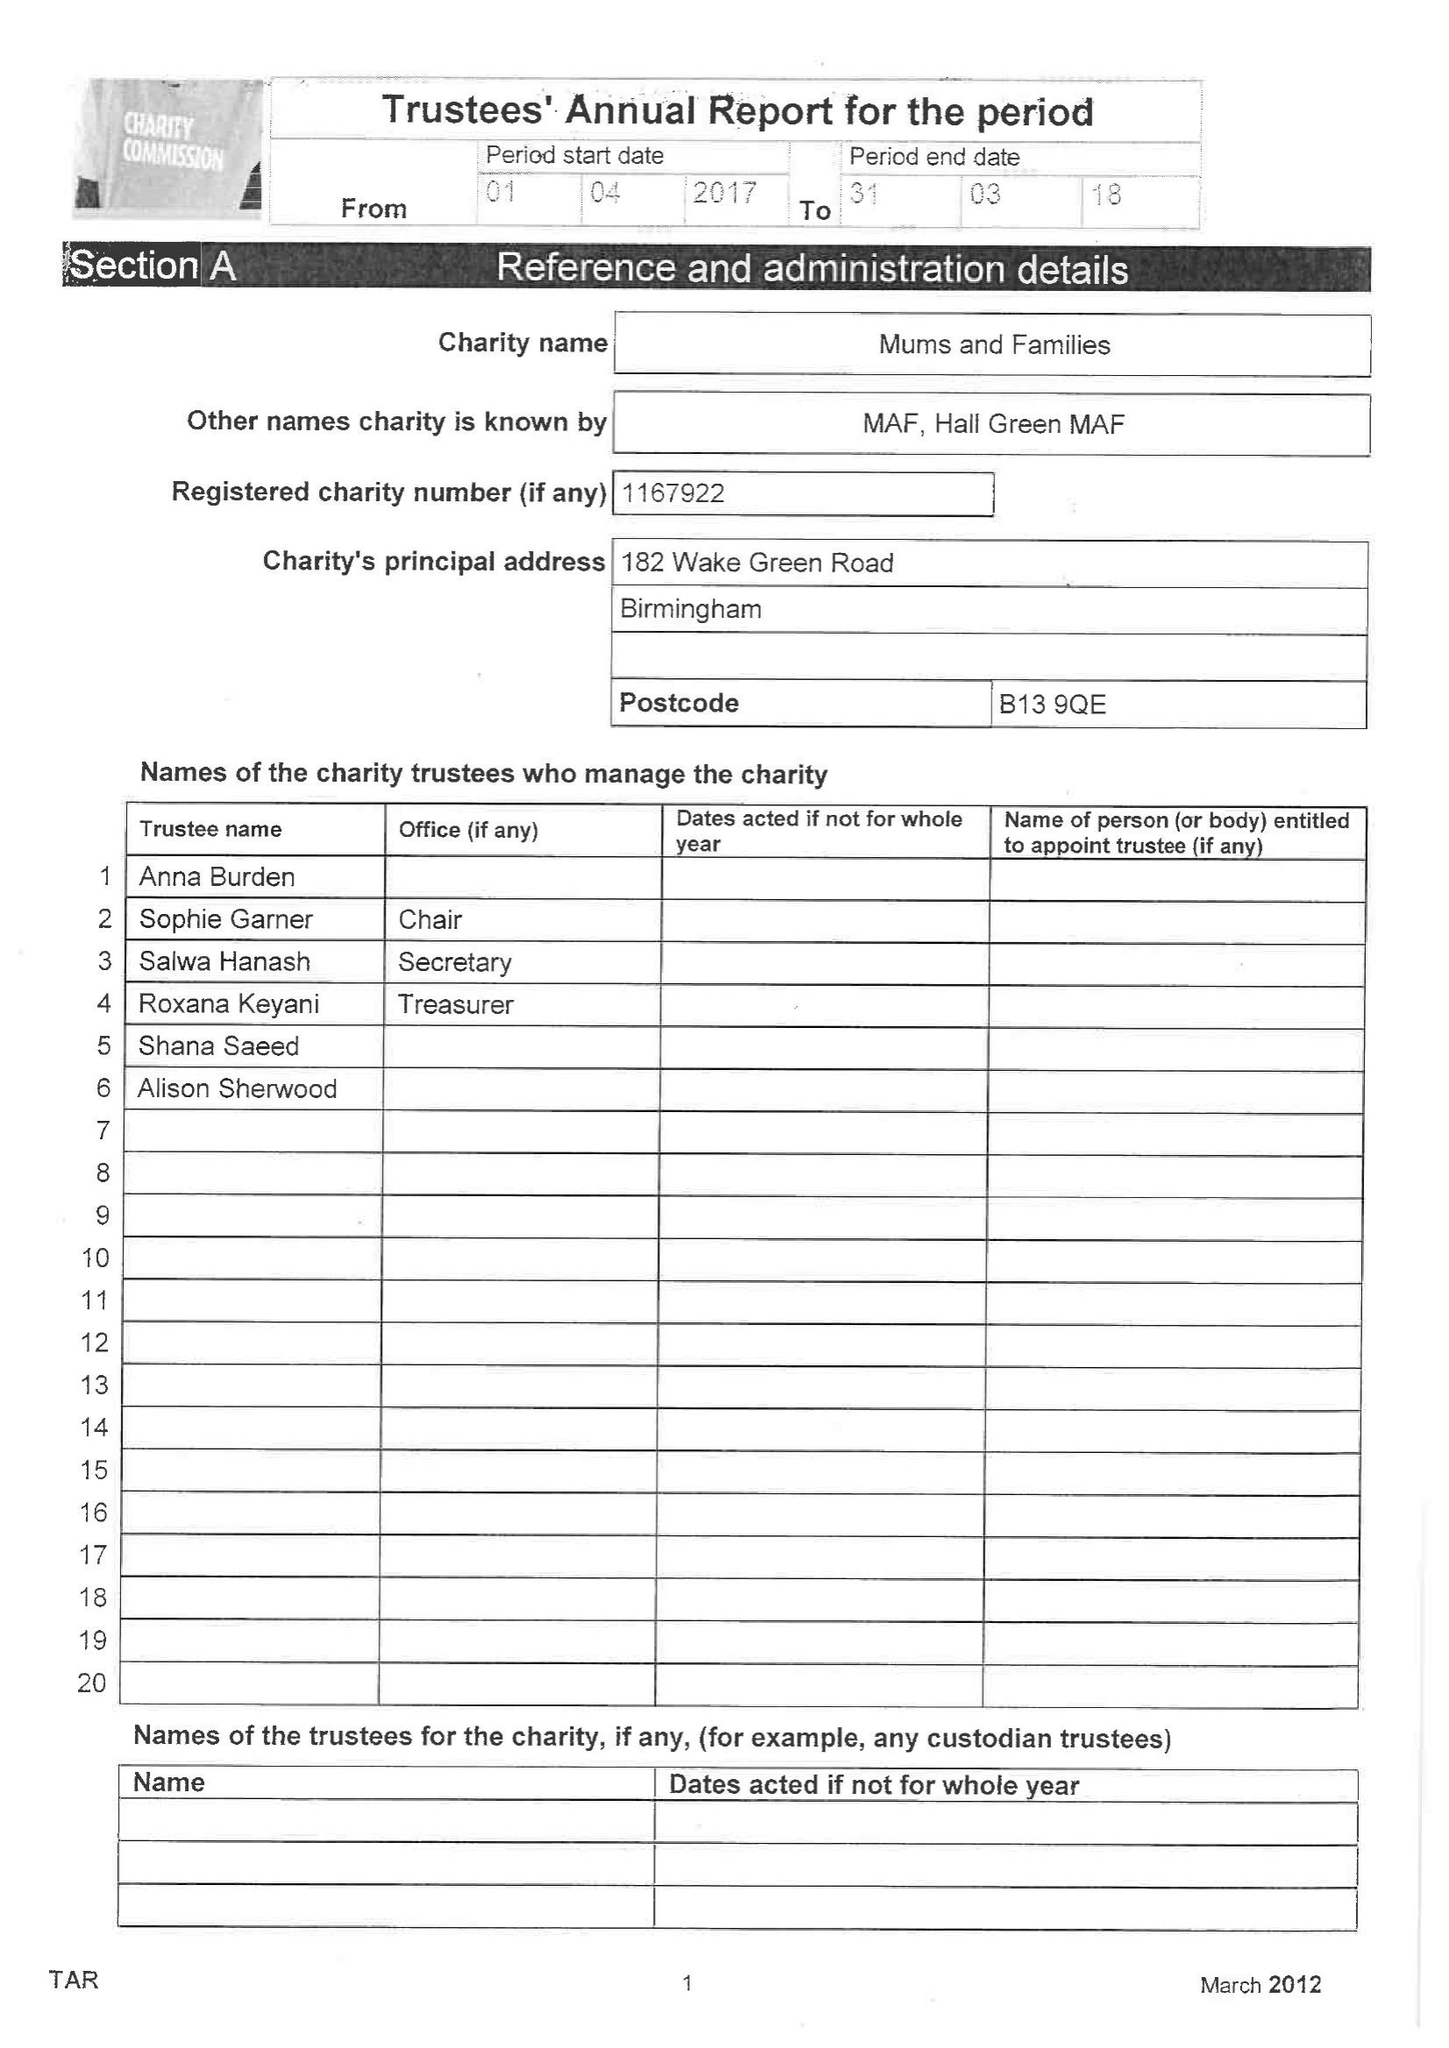What is the value for the address__street_line?
Answer the question using a single word or phrase. 182 WAKE GREEN ROAD 